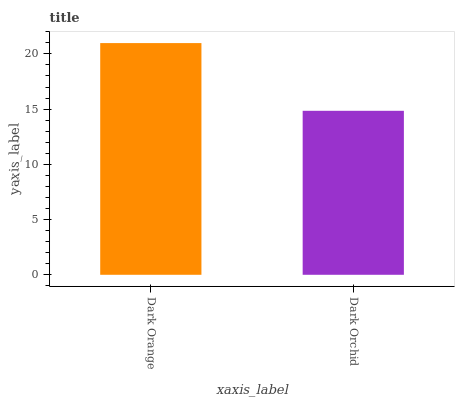Is Dark Orchid the minimum?
Answer yes or no. Yes. Is Dark Orange the maximum?
Answer yes or no. Yes. Is Dark Orchid the maximum?
Answer yes or no. No. Is Dark Orange greater than Dark Orchid?
Answer yes or no. Yes. Is Dark Orchid less than Dark Orange?
Answer yes or no. Yes. Is Dark Orchid greater than Dark Orange?
Answer yes or no. No. Is Dark Orange less than Dark Orchid?
Answer yes or no. No. Is Dark Orange the high median?
Answer yes or no. Yes. Is Dark Orchid the low median?
Answer yes or no. Yes. Is Dark Orchid the high median?
Answer yes or no. No. Is Dark Orange the low median?
Answer yes or no. No. 